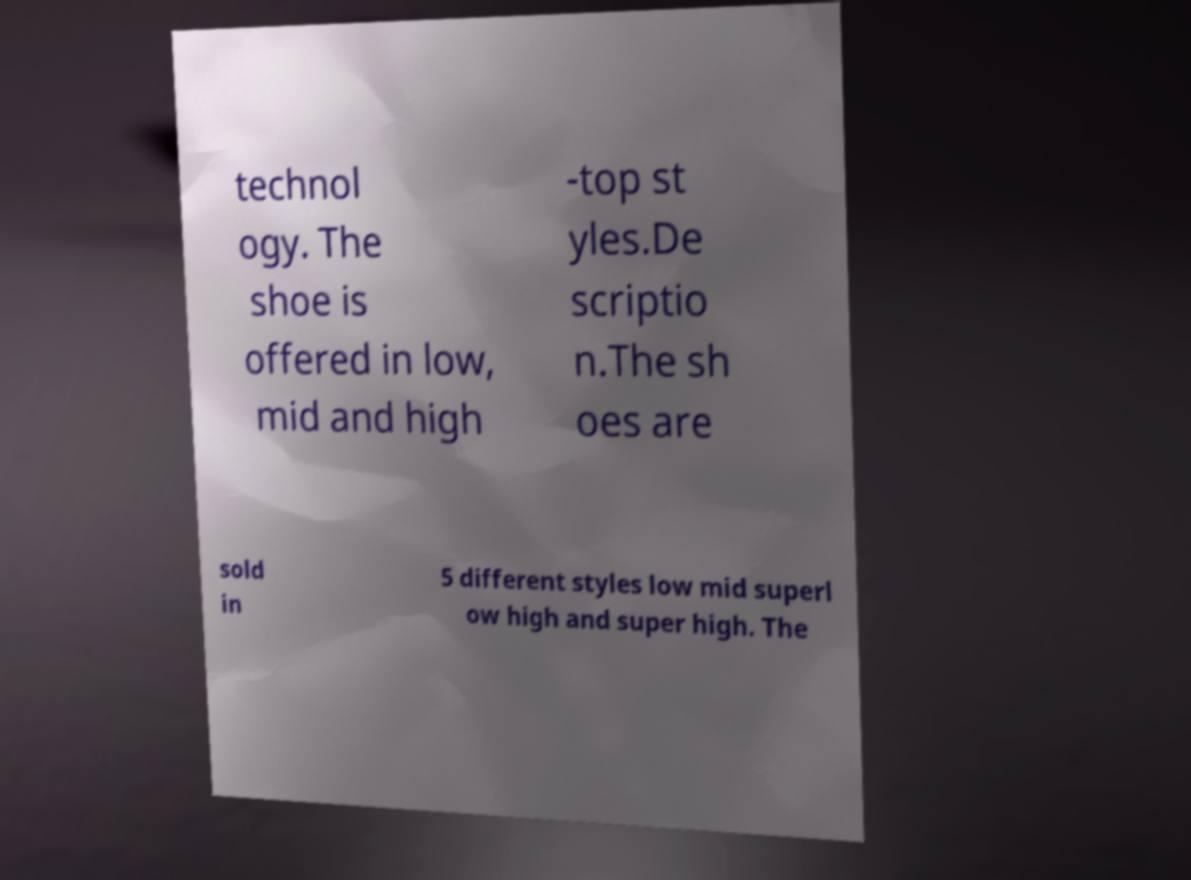Please identify and transcribe the text found in this image. technol ogy. The shoe is offered in low, mid and high -top st yles.De scriptio n.The sh oes are sold in 5 different styles low mid superl ow high and super high. The 